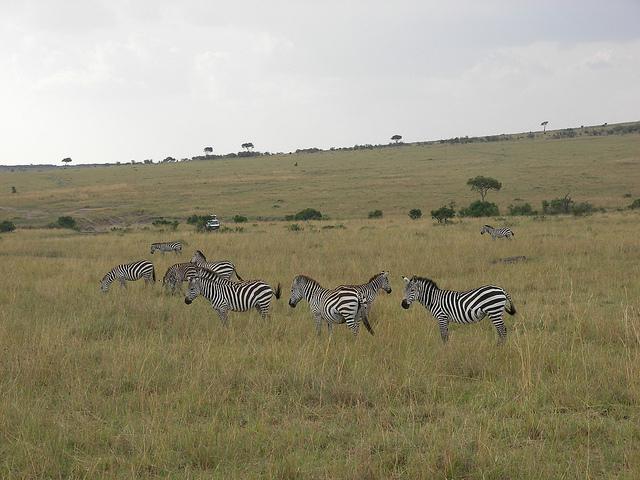Is the grass tall?
Quick response, please. Yes. Are these zebras free to graze wherever they like?
Give a very brief answer. Yes. Are the zebras wild or captive?
Give a very brief answer. Wild. Is the zebra running?
Give a very brief answer. No. Are these animals in captivity?
Quick response, please. No. How many zebras are there?
Write a very short answer. 9. How many zebra's are there?
Give a very brief answer. 9. 